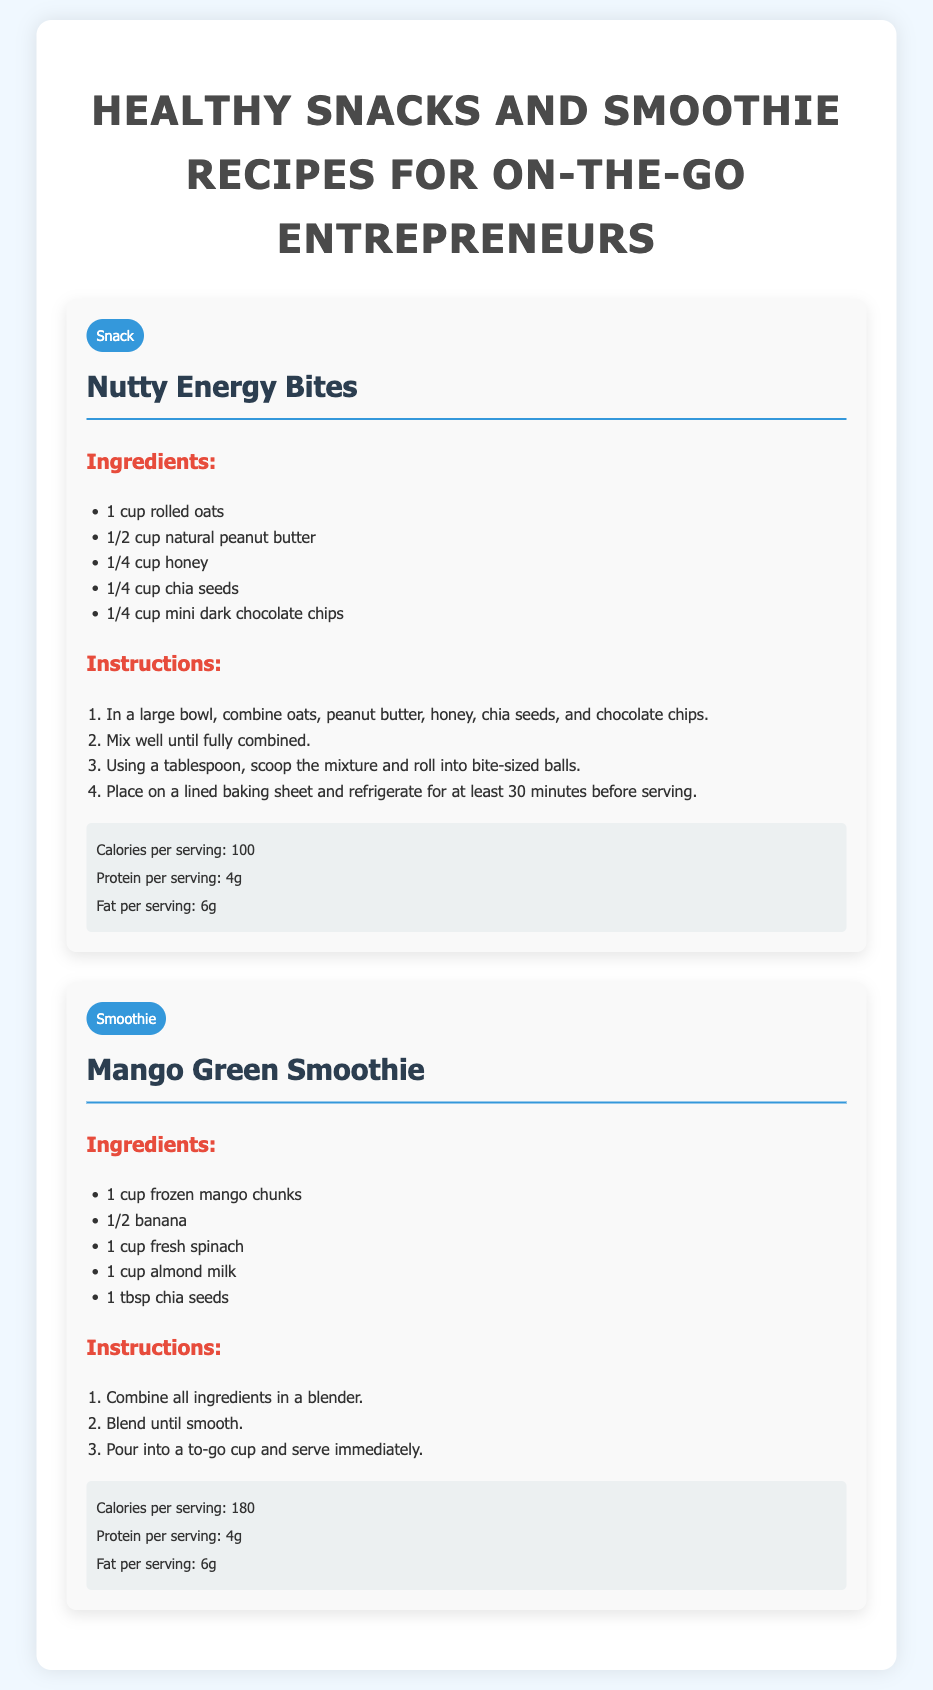What is the name of the first recipe? The first recipe is titled "Nutty Energy Bites."
Answer: Nutty Energy Bites How many carbohydrates are in a serving of the Mango Green Smoothie? The document does not specify the carbohydrates; it lists calories, protein, and fat only.
Answer: Not specified What ingredient is used for sweetness in Nutty Energy Bites? The sweetener used in Nutty Energy Bites is honey.
Answer: Honey How long should the Nutty Energy Bites be refrigerated before serving? The instructions indicate a refrigeration time of at least 30 minutes.
Answer: 30 minutes What is the main leafy green used in the Mango Green Smoothie? The main leafy green ingredient in the smoothie is fresh spinach.
Answer: Spinach What is the total number of ingredients for the Nutty Energy Bites recipe? There are five ingredients listed for the Nutty Energy Bites.
Answer: 5 What type of recipe is "Mango Green Smoothie"? The recipe type for the Mango Green Smoothie is labeled as a smoothie.
Answer: Smoothie How much protein is in a serving of Nutty Energy Bites? Each serving of Nutty Energy Bites contains 4 grams of protein.
Answer: 4g 